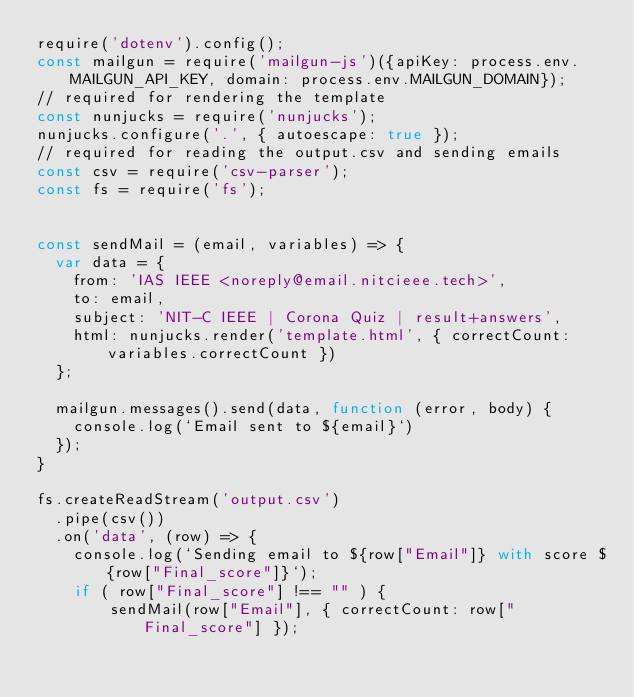<code> <loc_0><loc_0><loc_500><loc_500><_JavaScript_>require('dotenv').config();
const mailgun = require('mailgun-js')({apiKey: process.env.MAILGUN_API_KEY, domain: process.env.MAILGUN_DOMAIN});
// required for rendering the template
const nunjucks = require('nunjucks');
nunjucks.configure('.', { autoescape: true });
// required for reading the output.csv and sending emails
const csv = require('csv-parser');
const fs = require('fs');


const sendMail = (email, variables) => {
  var data = {
    from: 'IAS IEEE <noreply@email.nitcieee.tech>',
    to: email,
    subject: 'NIT-C IEEE | Corona Quiz | result+answers',
    html: nunjucks.render('template.html', { correctCount: variables.correctCount })
  };

  mailgun.messages().send(data, function (error, body) {
    console.log(`Email sent to ${email}`)
  });
}

fs.createReadStream('output.csv')
  .pipe(csv())
  .on('data', (row) => {
    console.log(`Sending email to ${row["Email"]} with score ${row["Final_score"]}`);
    if ( row["Final_score"] !== "" ) {
        sendMail(row["Email"], { correctCount: row["Final_score"] });</code> 